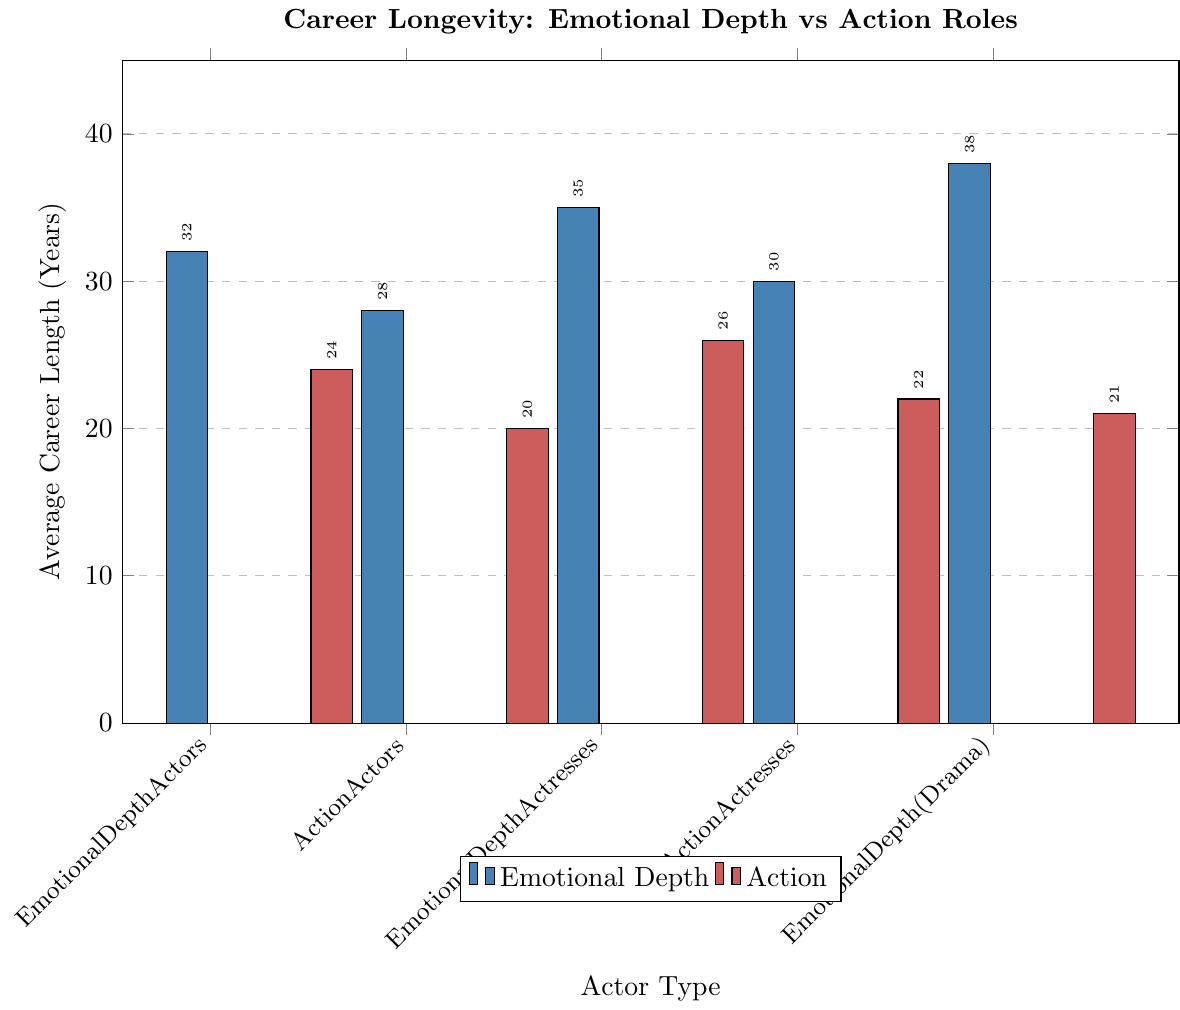Which actor type has the longest average career length? Compare the height of the bars representing different actor types. The bar for "Emotional Depth (Award Winners)" is the tallest, indicating the longest average career length.
Answer: Emotional Depth (Award Winners) What is the difference in average career length between Emotional Depth Actors and Action Actors? Look at the bars for Emotional Depth Actors and Action Actors. Subtract the height of the Action Actors bar (24) from the height of the Emotional Depth Actors bar (32).
Answer: 8 years Which group has the shortest average career length? Compare all the bars' heights and find the shortest one. The bar for "Action (Stunt-heavy Roles)" is the shortest.
Answer: Action (Stunt-heavy Roles) How much longer is the average career of Emotional Depth Actresses compared to Action Actresses? Subtract the average career length of Action Actresses (20) from that of Emotional Depth Actresses (28).
Answer: 8 years Among actors and actresses known for emotional depth, who has a longer average career, those in drama or independent films? Compare the bars for "Emotional Depth (Drama)" and "Emotional Depth (Independent Films)". The bar for Emotional Depth (Drama) is taller.
Answer: Emotional Depth (Drama) What is the average career length of actors and actresses known for action roles combined? Add the career lengths of Action Actors (24) and Action Actresses (20), then divide by 2 to get the average. (24 + 20) / 2 = 22
Answer: 22 years Between Emotional Depth Actors and Emotional Depth Actresses, who has a longer average career, and by how much? Compare the heights of the bars for Emotional Depth Actors (32) and Emotional Depth Actresses (28). Subtract the shorter from the longer. 32 - 28 = 4
Answer: Emotional Depth Actors by 4 years What is the overall trend in career longevity between Emotional Depth and Action roles? Observe the heights of the bars for all emotional depth and action categories. Emotional Depth roles generally have taller bars, indicating longer career lengths.
Answer: Emotional Depth roles generally have longer careers 